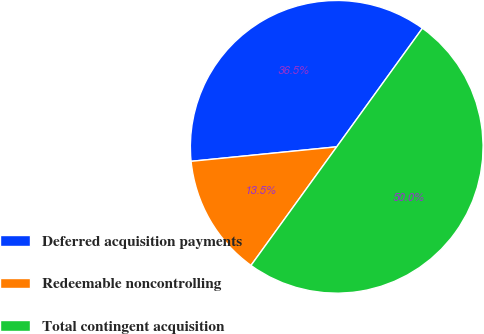<chart> <loc_0><loc_0><loc_500><loc_500><pie_chart><fcel>Deferred acquisition payments<fcel>Redeemable noncontrolling<fcel>Total contingent acquisition<nl><fcel>36.54%<fcel>13.46%<fcel>50.0%<nl></chart> 